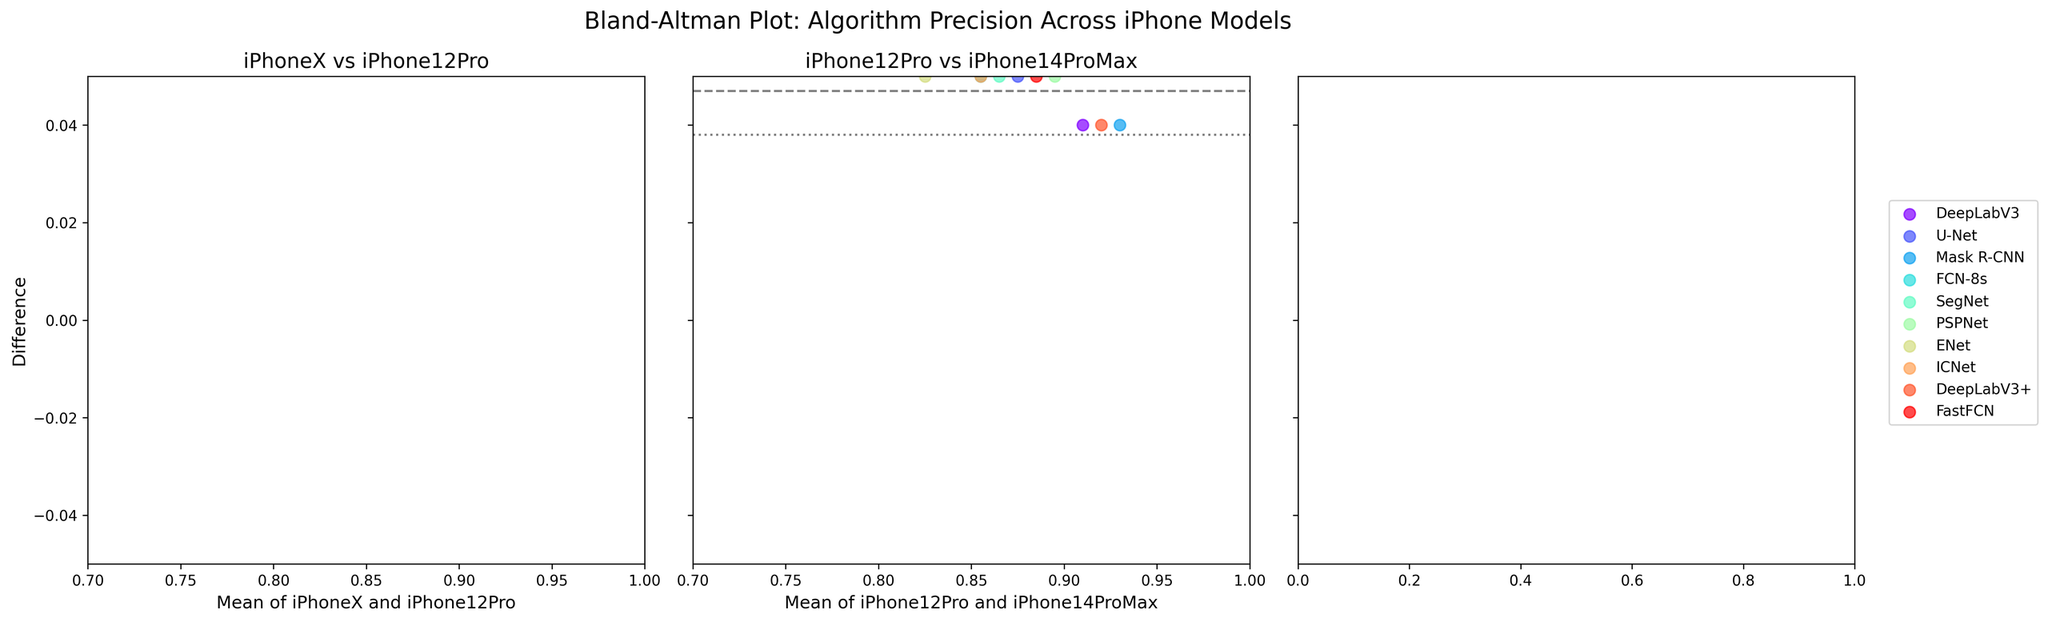What is the title of the figure? The title is displayed at the top of the figure, which usually gives a summary of what the figure is about. The title in this case is placed centrally above the three subplots.
Answer: Bland-Altman Plot: Algorithm Precision Across iPhone Models How many iPhone model comparisons are shown in the figure? The figure displays three subplots, each comparing the precision between two iPhone models. Looking at the titles of these subplots reveals the comparisons.
Answer: 2 Which segmentation algorithm shows a difference above 0.03 for iPhoneX vs iPhone12Pro? In the subplot titled "iPhoneX vs iPhone12Pro", we can see different colored dots representing each algorithm. By observing the vertical position of the dots, we identify which ones fall above the 0.03 difference mark.
Answer: Mask R-CNN What are the mean lines of difference for iPhoneX vs iPhone12Pro and iPhone12Pro vs iPhone14ProMax? The mean lines of difference are represented by dashed horizontal lines in each subplot. We can read the values of these lines from the vertical axis where they intersect.
Answer: 0.04 and 0.02 Which algorithm has the smallest mean difference between iPhoneX and iPhone12Pro? We examine the `iPhoneX vs iPhone12Pro` subplot and find the dot closest to the dashed mean difference line. The closest dot represents the algorithm with the smallest mean difference.
Answer: ENet For the mean difference between iPhone12Pro and iPhone14ProMax, which algorithm has the largest value? By looking at the subplot `iPhone12Pro vs iPhone14ProMax`, we check the vertical positioning of each dot representing algorithms. The dot at the highest position in the direction of the mean difference line indicates the largest value.
Answer: Mask R-CNN What does the dashed line represent in each subplot? The dashed horizontal lines in each subplot represent the mean difference of precision between the two iPhone models being compared. This line helps to understand the average change in precision across algorithms.
Answer: Mean difference What is the range of differences for the majority of algorithms in the iPhoneX vs iPhone12Pro plot? We look at the `iPhoneX vs iPhone12Pro` subplot and observe the spread of the majority of the dots. Most of the algorithms fall within two specific difference values along the vertical axis.
Answer: -0.03 to 0.03 How many algorithms fall outside the 1.96 standard deviation lines in the iPhoneX vs iPhone12Pro comparison? We focus on the subplot `iPhoneX vs iPhone12Pro` and count the number of dots (algorithms) situated outside the dotted standard deviation lines. These lines are usually placed at ±1.96 standard deviations from the mean.
Answer: 1 